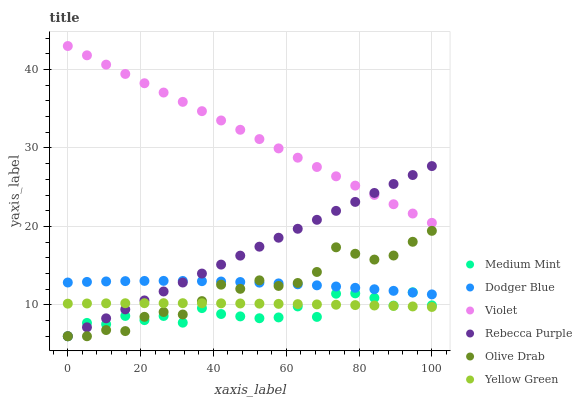Does Medium Mint have the minimum area under the curve?
Answer yes or no. Yes. Does Violet have the maximum area under the curve?
Answer yes or no. Yes. Does Yellow Green have the minimum area under the curve?
Answer yes or no. No. Does Yellow Green have the maximum area under the curve?
Answer yes or no. No. Is Rebecca Purple the smoothest?
Answer yes or no. Yes. Is Medium Mint the roughest?
Answer yes or no. Yes. Is Yellow Green the smoothest?
Answer yes or no. No. Is Yellow Green the roughest?
Answer yes or no. No. Does Medium Mint have the lowest value?
Answer yes or no. Yes. Does Yellow Green have the lowest value?
Answer yes or no. No. Does Violet have the highest value?
Answer yes or no. Yes. Does Dodger Blue have the highest value?
Answer yes or no. No. Is Dodger Blue less than Violet?
Answer yes or no. Yes. Is Violet greater than Medium Mint?
Answer yes or no. Yes. Does Rebecca Purple intersect Yellow Green?
Answer yes or no. Yes. Is Rebecca Purple less than Yellow Green?
Answer yes or no. No. Is Rebecca Purple greater than Yellow Green?
Answer yes or no. No. Does Dodger Blue intersect Violet?
Answer yes or no. No. 